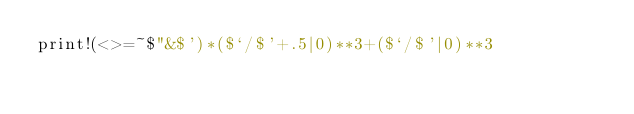<code> <loc_0><loc_0><loc_500><loc_500><_Perl_>print!(<>=~$"&$')*($`/$'+.5|0)**3+($`/$'|0)**3</code> 